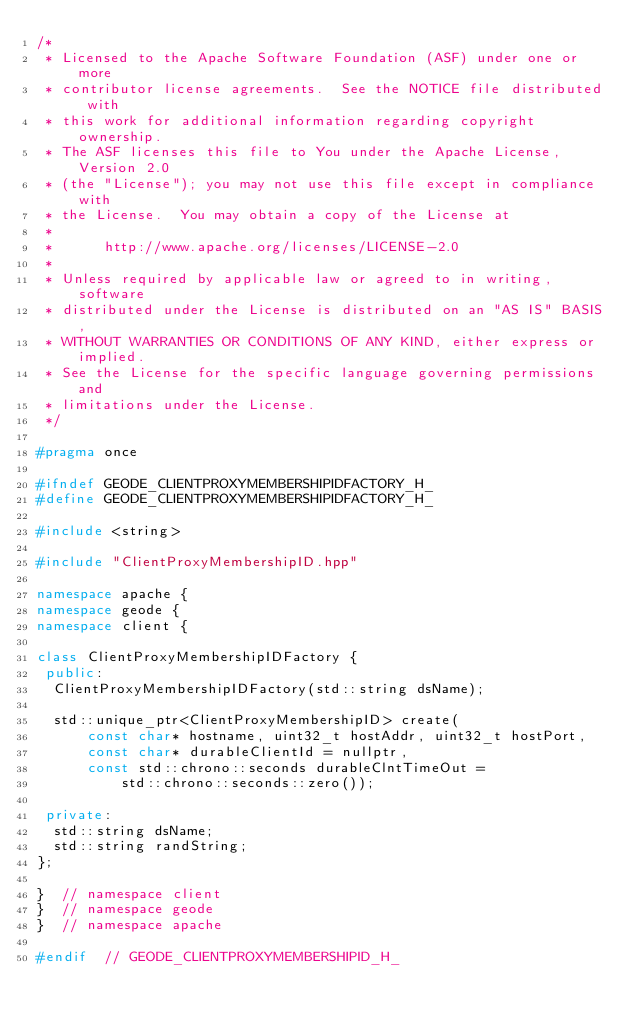<code> <loc_0><loc_0><loc_500><loc_500><_C++_>/*
 * Licensed to the Apache Software Foundation (ASF) under one or more
 * contributor license agreements.  See the NOTICE file distributed with
 * this work for additional information regarding copyright ownership.
 * The ASF licenses this file to You under the Apache License, Version 2.0
 * (the "License"); you may not use this file except in compliance with
 * the License.  You may obtain a copy of the License at
 *
 *      http://www.apache.org/licenses/LICENSE-2.0
 *
 * Unless required by applicable law or agreed to in writing, software
 * distributed under the License is distributed on an "AS IS" BASIS,
 * WITHOUT WARRANTIES OR CONDITIONS OF ANY KIND, either express or implied.
 * See the License for the specific language governing permissions and
 * limitations under the License.
 */

#pragma once

#ifndef GEODE_CLIENTPROXYMEMBERSHIPIDFACTORY_H_
#define GEODE_CLIENTPROXYMEMBERSHIPIDFACTORY_H_

#include <string>

#include "ClientProxyMembershipID.hpp"

namespace apache {
namespace geode {
namespace client {

class ClientProxyMembershipIDFactory {
 public:
  ClientProxyMembershipIDFactory(std::string dsName);

  std::unique_ptr<ClientProxyMembershipID> create(
      const char* hostname, uint32_t hostAddr, uint32_t hostPort,
      const char* durableClientId = nullptr,
      const std::chrono::seconds durableClntTimeOut =
          std::chrono::seconds::zero());

 private:
  std::string dsName;
  std::string randString;
};

}  // namespace client
}  // namespace geode
}  // namespace apache

#endif  // GEODE_CLIENTPROXYMEMBERSHIPID_H_
</code> 